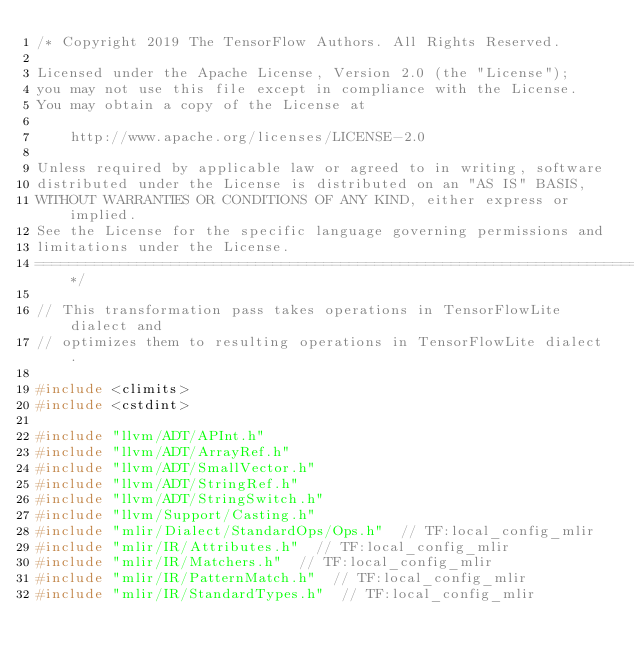<code> <loc_0><loc_0><loc_500><loc_500><_C++_>/* Copyright 2019 The TensorFlow Authors. All Rights Reserved.

Licensed under the Apache License, Version 2.0 (the "License");
you may not use this file except in compliance with the License.
You may obtain a copy of the License at

    http://www.apache.org/licenses/LICENSE-2.0

Unless required by applicable law or agreed to in writing, software
distributed under the License is distributed on an "AS IS" BASIS,
WITHOUT WARRANTIES OR CONDITIONS OF ANY KIND, either express or implied.
See the License for the specific language governing permissions and
limitations under the License.
==============================================================================*/

// This transformation pass takes operations in TensorFlowLite dialect and
// optimizes them to resulting operations in TensorFlowLite dialect.

#include <climits>
#include <cstdint>

#include "llvm/ADT/APInt.h"
#include "llvm/ADT/ArrayRef.h"
#include "llvm/ADT/SmallVector.h"
#include "llvm/ADT/StringRef.h"
#include "llvm/ADT/StringSwitch.h"
#include "llvm/Support/Casting.h"
#include "mlir/Dialect/StandardOps/Ops.h"  // TF:local_config_mlir
#include "mlir/IR/Attributes.h"  // TF:local_config_mlir
#include "mlir/IR/Matchers.h"  // TF:local_config_mlir
#include "mlir/IR/PatternMatch.h"  // TF:local_config_mlir
#include "mlir/IR/StandardTypes.h"  // TF:local_config_mlir</code> 